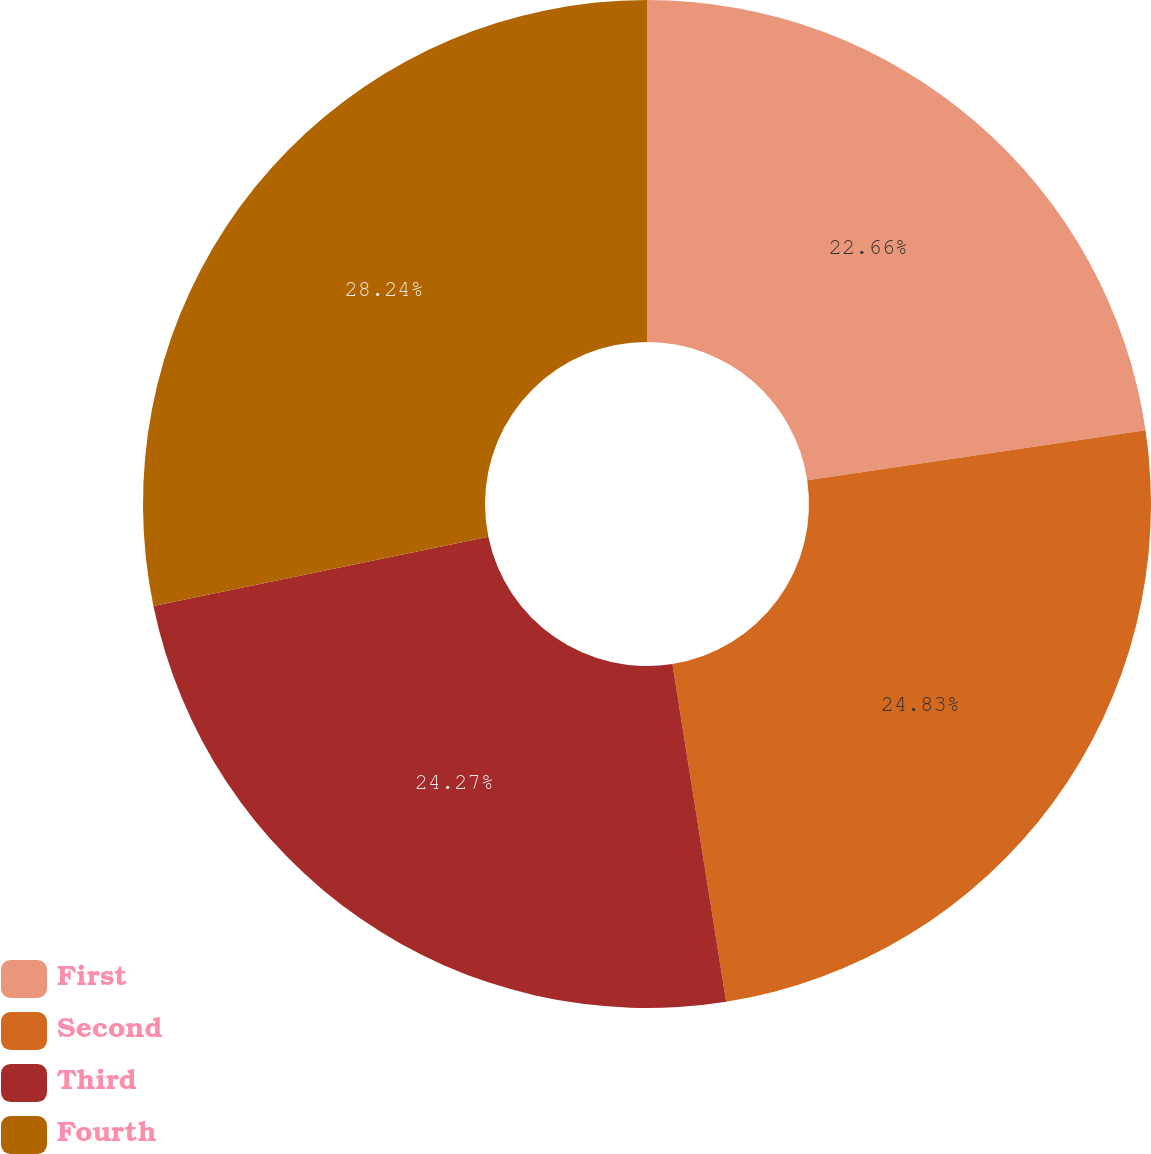Convert chart to OTSL. <chart><loc_0><loc_0><loc_500><loc_500><pie_chart><fcel>First<fcel>Second<fcel>Third<fcel>Fourth<nl><fcel>22.66%<fcel>24.83%<fcel>24.27%<fcel>28.24%<nl></chart> 